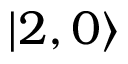<formula> <loc_0><loc_0><loc_500><loc_500>| 2 , 0 \rangle</formula> 